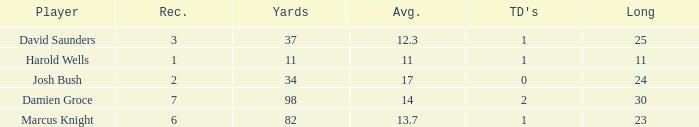How many TDs are there were the long is smaller than 23? 1.0. 